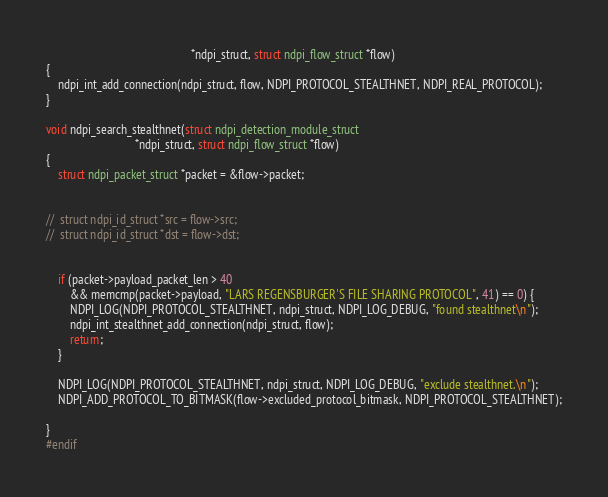Convert code to text. <code><loc_0><loc_0><loc_500><loc_500><_C_>												 *ndpi_struct, struct ndpi_flow_struct *flow)
{
	ndpi_int_add_connection(ndpi_struct, flow, NDPI_PROTOCOL_STEALTHNET, NDPI_REAL_PROTOCOL);
}

void ndpi_search_stealthnet(struct ndpi_detection_module_struct
							  *ndpi_struct, struct ndpi_flow_struct *flow)
{
	struct ndpi_packet_struct *packet = &flow->packet;
	

//  struct ndpi_id_struct *src = flow->src;
//  struct ndpi_id_struct *dst = flow->dst;


	if (packet->payload_packet_len > 40
		&& memcmp(packet->payload, "LARS REGENSBURGER'S FILE SHARING PROTOCOL", 41) == 0) {
		NDPI_LOG(NDPI_PROTOCOL_STEALTHNET, ndpi_struct, NDPI_LOG_DEBUG, "found stealthnet\n");
		ndpi_int_stealthnet_add_connection(ndpi_struct, flow);
		return;
	}

	NDPI_LOG(NDPI_PROTOCOL_STEALTHNET, ndpi_struct, NDPI_LOG_DEBUG, "exclude stealthnet.\n");
	NDPI_ADD_PROTOCOL_TO_BITMASK(flow->excluded_protocol_bitmask, NDPI_PROTOCOL_STEALTHNET);

}
#endif
</code> 